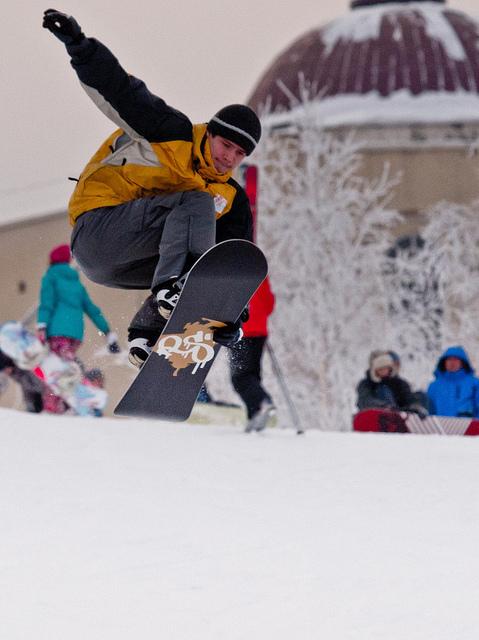What is the man flying through the air on?
Be succinct. Snowboard. Why can't you do this sport at the beach?
Quick response, please. No snow. What brand of coat is he wearing?
Keep it brief. North face. 